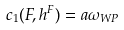<formula> <loc_0><loc_0><loc_500><loc_500>c _ { 1 } ( F , h ^ { F } ) = a \omega _ { W P }</formula> 